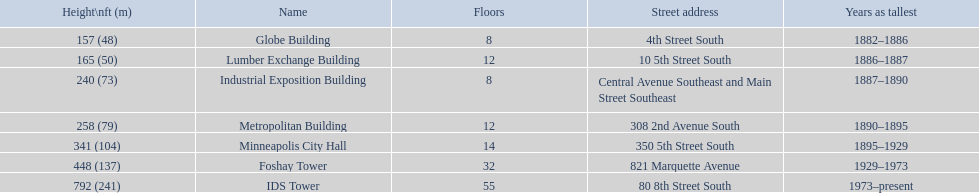What years was 240 ft considered tall? 1887–1890. What building held this record? Industrial Exposition Building. 